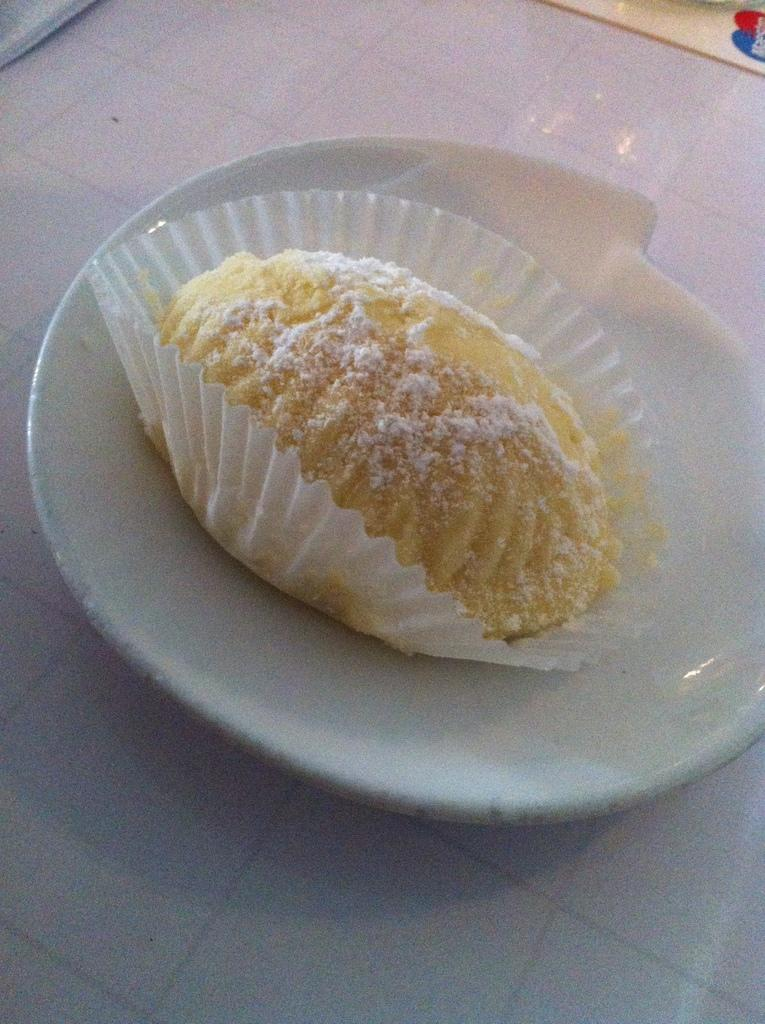What is on the plate that is visible in the image? There is food in a plate in the image. Where is the plate located in the image? The plate is placed on the floor. How does the crowd affect the food on the plate in the image? There is no crowd present in the image, so it cannot affect the food on the plate. 